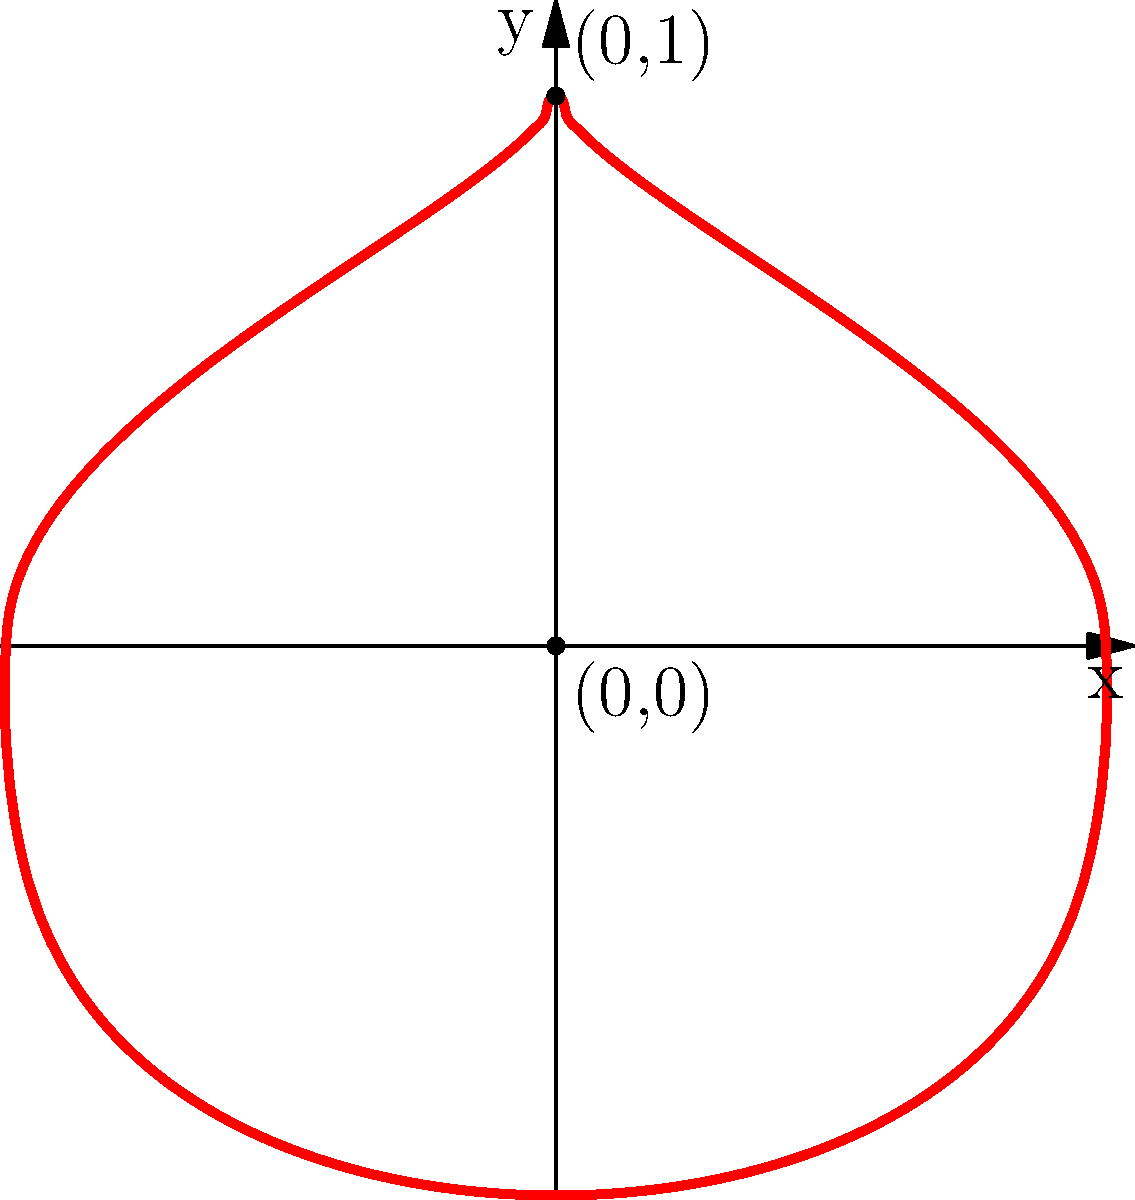Tarciane is preparing a special Mother's Day card for you. She wants to draw a heart shape on a coordinate grid to symbolize your love. The heart shape is formed by two equations:

Top part: $y = \sqrt{1-|x|^{2/3}}$
Bottom part: $y = -\sqrt[3]{1-x^2}$

What are the coordinates of the highest point of the heart? Let's approach this step-by-step:

1. The heart shape is symmetrical along the y-axis, so the highest point will be at x = 0.

2. To find the y-coordinate of the highest point, we need to use the equation for the top part of the heart:
   $y = \sqrt{1-|x|^{2/3}}$

3. When x = 0, |x| is also 0, so we can simplify:
   $y = \sqrt{1-0^{2/3}} = \sqrt{1-0} = \sqrt{1} = 1$

4. Therefore, the highest point of the heart is at (0, 1).

5. We can confirm this by looking at the graph, where we see the peak of the heart at the point (0, 1).

This point represents the maximum height of the heart shape, symbolizing the peak of a mother's love for her child.
Answer: (0, 1) 